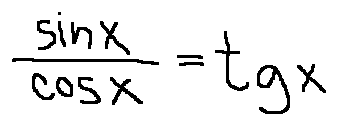Convert formula to latex. <formula><loc_0><loc_0><loc_500><loc_500>\frac { \sin x } { \cos x } = t g x</formula> 